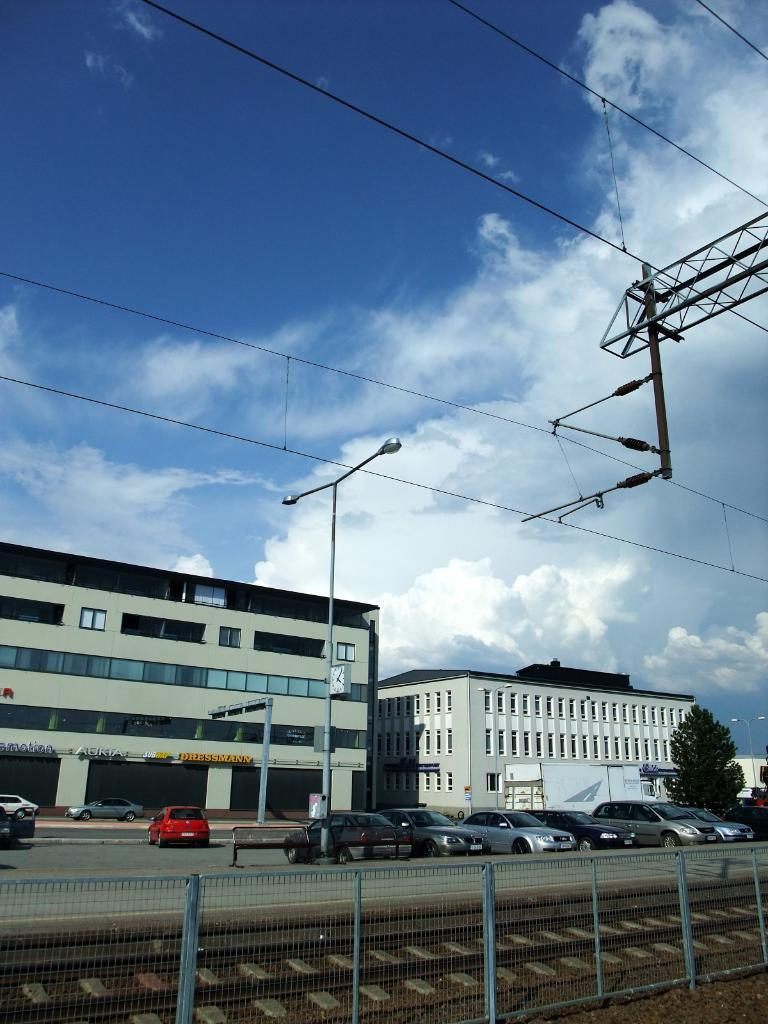What is the condition of the sky in the image? The sky is cloudy in the image. What structures can be seen in the image? There are light poles and a fence in the image. What type of transportation infrastructure is present in the image? There is a train track in the image. What types of vehicles are visible in the image? There are vehicles in the image. What natural element is present in the image? There is a tree in the image. What can be seen in the background of the image? There are buildings with windows in the background of the image. What type of mask is being worn by the tree in the image? There is no mask present in the image, and the tree is not wearing anything. What type of machine is being used to curve the train track in the image? There is no machine present in the image, and the train track is not being curved. 